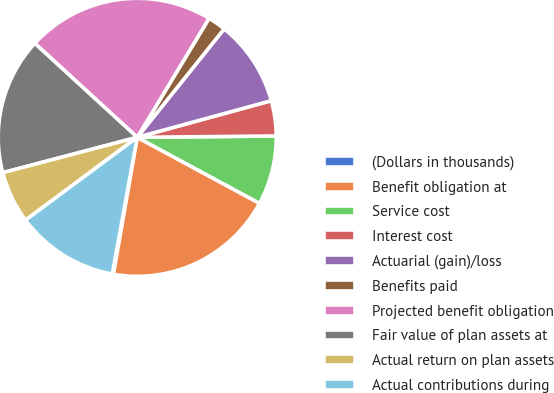<chart> <loc_0><loc_0><loc_500><loc_500><pie_chart><fcel>(Dollars in thousands)<fcel>Benefit obligation at<fcel>Service cost<fcel>Interest cost<fcel>Actuarial (gain)/loss<fcel>Benefits paid<fcel>Projected benefit obligation<fcel>Fair value of plan assets at<fcel>Actual return on plan assets<fcel>Actual contributions during<nl><fcel>0.14%<fcel>19.86%<fcel>8.03%<fcel>4.09%<fcel>10.0%<fcel>2.11%<fcel>21.83%<fcel>15.91%<fcel>6.06%<fcel>11.97%<nl></chart> 